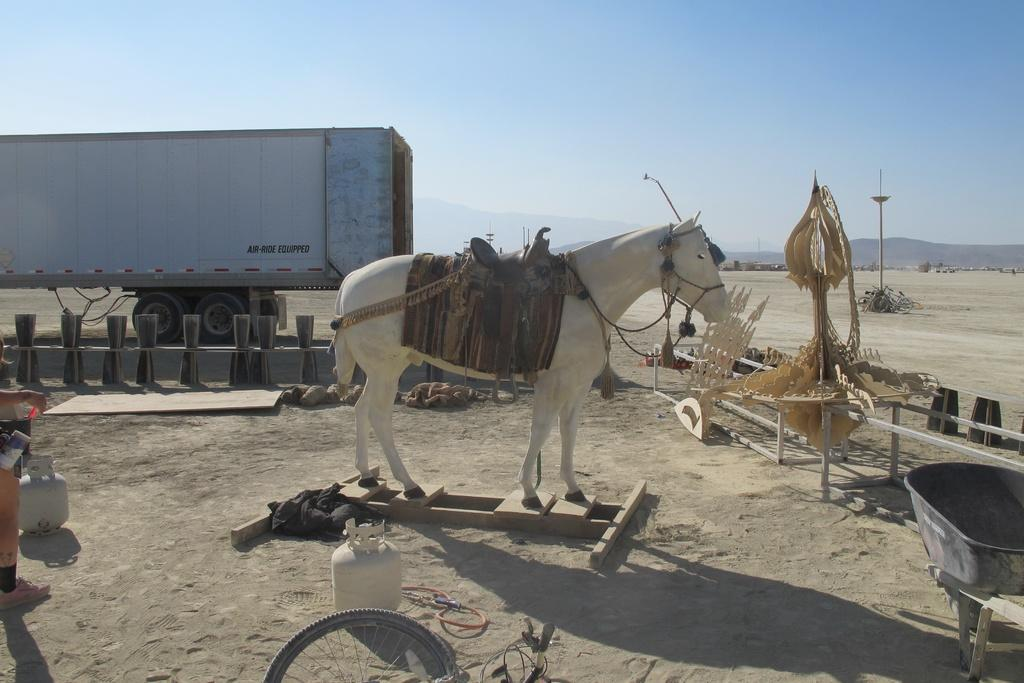What is the main setting of the image? The image depicts a vast land. What type of vehicle can be seen on the land? There is a vehicle on the land. What kind of statue is present on the land? There is a horse statue on the land. What type of objects are made of wood and present on the land? Wooden objects are present on the land. What type of structure is present on the land? There is a tier on the land. What type of storage containers are visible on the land? Containers are visible on the land. What type of barrier is present on the land? Fencing is present on the land. What type of vertical structure is present on the land? A pole is present on the land. What is visible at the top of the image? The sky is visible at the top of the image. What type of line is being acted out by the horse statue in the image? There is no line being acted out by the horse statue in the image, as it is a statue and not a living being capable of speaking or acting. 